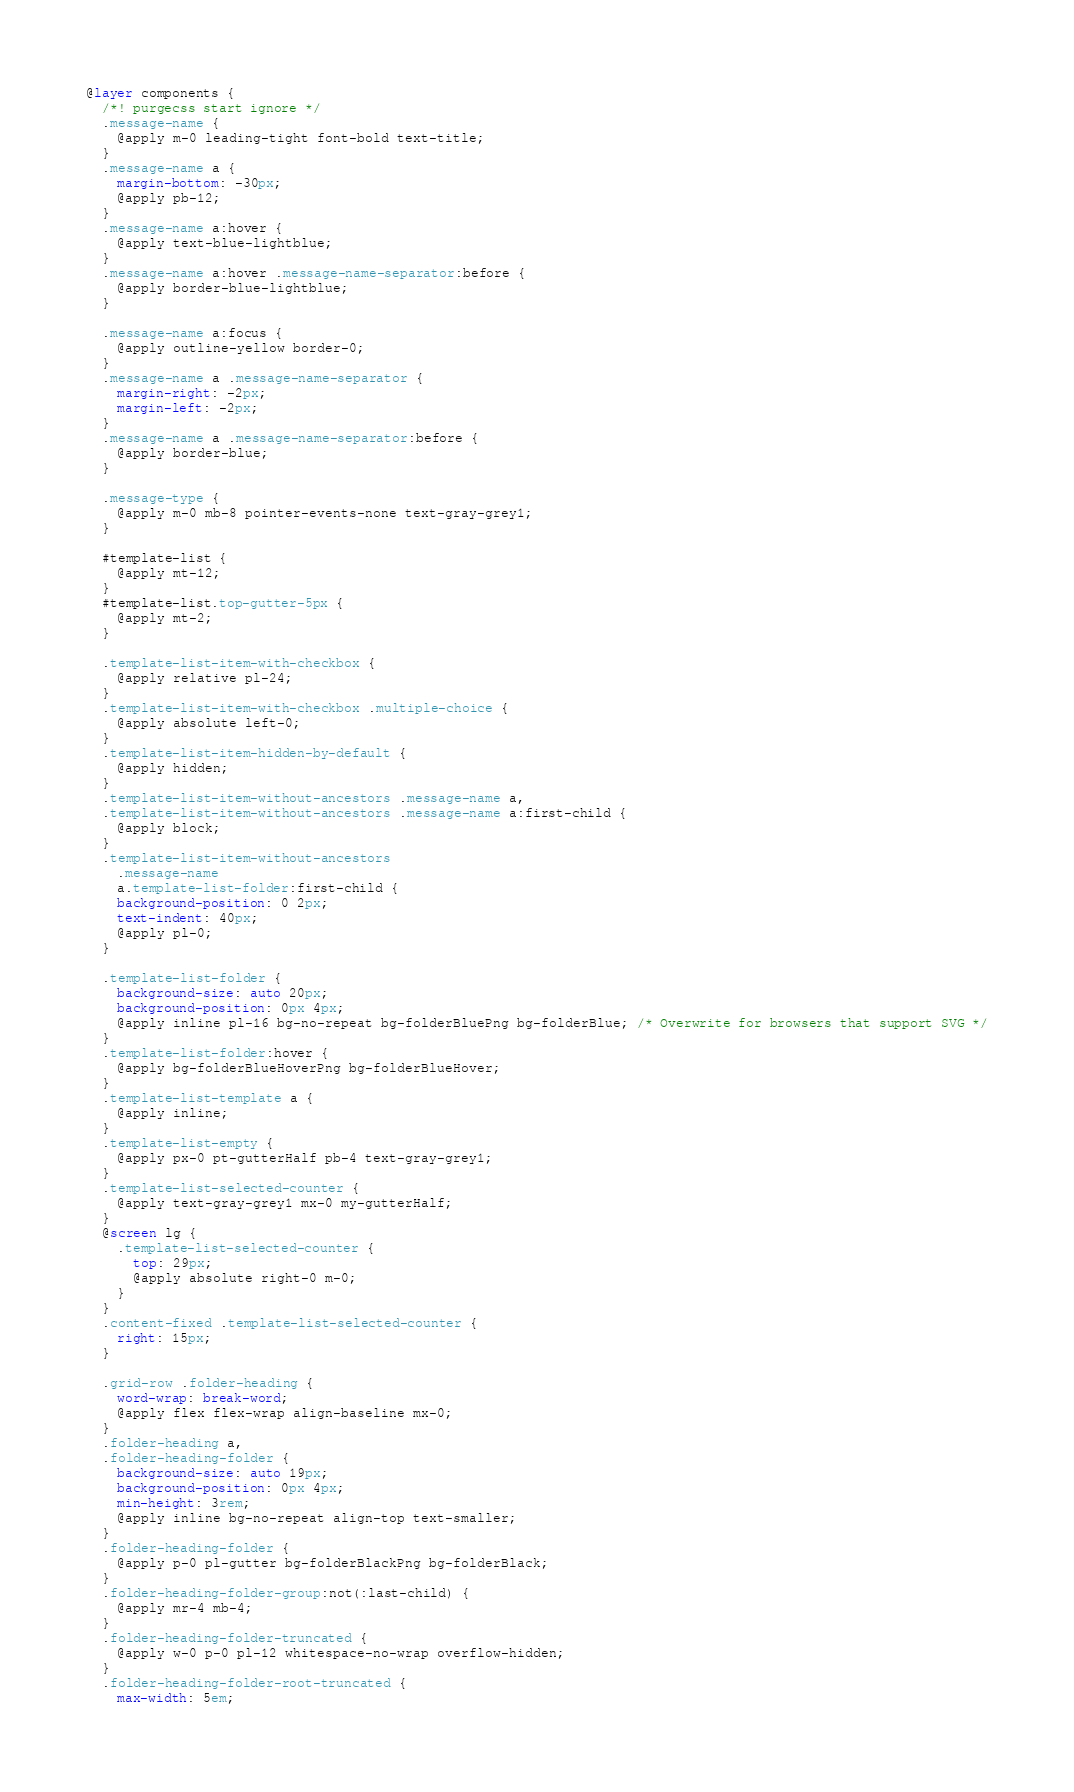<code> <loc_0><loc_0><loc_500><loc_500><_CSS_>@layer components {
  /*! purgecss start ignore */
  .message-name {
    @apply m-0 leading-tight font-bold text-title;
  }
  .message-name a {
    margin-bottom: -30px;
    @apply pb-12;
  }
  .message-name a:hover {
    @apply text-blue-lightblue;
  }
  .message-name a:hover .message-name-separator:before {
    @apply border-blue-lightblue;
  }

  .message-name a:focus {
    @apply outline-yellow border-0;
  }
  .message-name a .message-name-separator {
    margin-right: -2px;
    margin-left: -2px;
  }
  .message-name a .message-name-separator:before {
    @apply border-blue;
  }

  .message-type {
    @apply m-0 mb-8 pointer-events-none text-gray-grey1;
  }

  #template-list {
    @apply mt-12;
  }
  #template-list.top-gutter-5px {
    @apply mt-2;
  }

  .template-list-item-with-checkbox {
    @apply relative pl-24;
  }
  .template-list-item-with-checkbox .multiple-choice {
    @apply absolute left-0;
  }
  .template-list-item-hidden-by-default {
    @apply hidden;
  }
  .template-list-item-without-ancestors .message-name a,
  .template-list-item-without-ancestors .message-name a:first-child {
    @apply block;
  }
  .template-list-item-without-ancestors
    .message-name
    a.template-list-folder:first-child {
    background-position: 0 2px;
    text-indent: 40px;
    @apply pl-0;
  }

  .template-list-folder {
    background-size: auto 20px;
    background-position: 0px 4px;
    @apply inline pl-16 bg-no-repeat bg-folderBluePng bg-folderBlue; /* Overwrite for browsers that support SVG */
  }
  .template-list-folder:hover {
    @apply bg-folderBlueHoverPng bg-folderBlueHover;
  }
  .template-list-template a {
    @apply inline;
  }
  .template-list-empty {
    @apply px-0 pt-gutterHalf pb-4 text-gray-grey1;
  }
  .template-list-selected-counter {
    @apply text-gray-grey1 mx-0 my-gutterHalf;
  }
  @screen lg {
    .template-list-selected-counter {
      top: 29px;
      @apply absolute right-0 m-0;
    }
  }
  .content-fixed .template-list-selected-counter {
    right: 15px;
  }

  .grid-row .folder-heading {
    word-wrap: break-word;
    @apply flex flex-wrap align-baseline mx-0;
  }
  .folder-heading a,
  .folder-heading-folder {
    background-size: auto 19px;
    background-position: 0px 4px;
    min-height: 3rem;
    @apply inline bg-no-repeat align-top text-smaller;
  }
  .folder-heading-folder {
    @apply p-0 pl-gutter bg-folderBlackPng bg-folderBlack;
  }
  .folder-heading-folder-group:not(:last-child) {
    @apply mr-4 mb-4;
  }
  .folder-heading-folder-truncated {
    @apply w-0 p-0 pl-12 whitespace-no-wrap overflow-hidden;
  }
  .folder-heading-folder-root-truncated {
    max-width: 5em;</code> 